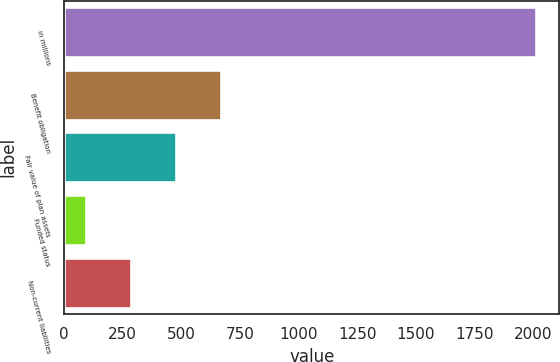Convert chart to OTSL. <chart><loc_0><loc_0><loc_500><loc_500><bar_chart><fcel>in millions<fcel>Benefit obligation<fcel>Fair value of plan assets<fcel>Funded status<fcel>Non-current liabilities<nl><fcel>2011<fcel>669.8<fcel>478.2<fcel>95<fcel>286.6<nl></chart> 